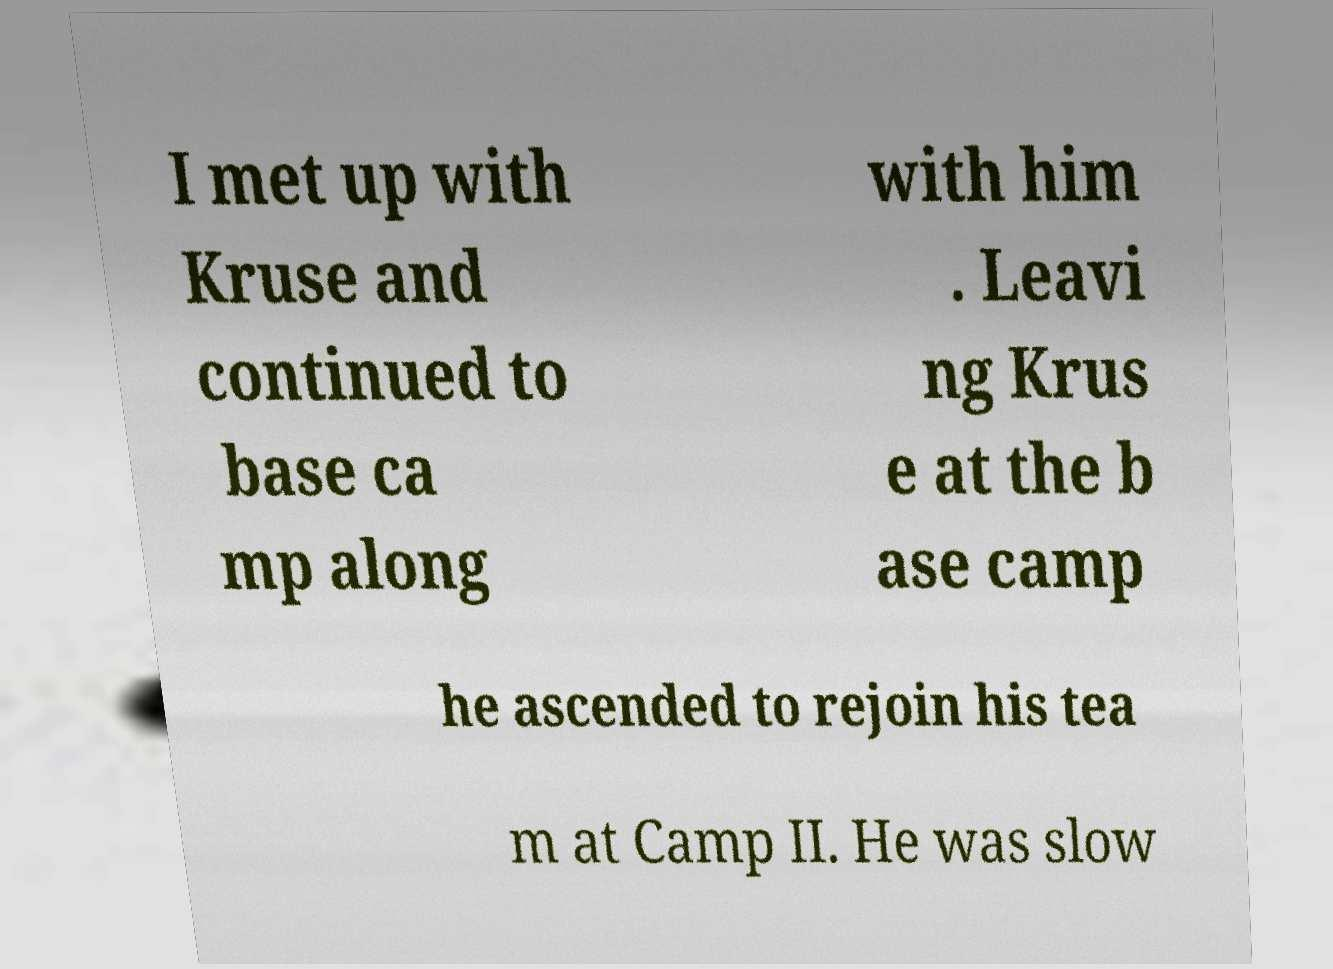There's text embedded in this image that I need extracted. Can you transcribe it verbatim? I met up with Kruse and continued to base ca mp along with him . Leavi ng Krus e at the b ase camp he ascended to rejoin his tea m at Camp II. He was slow 